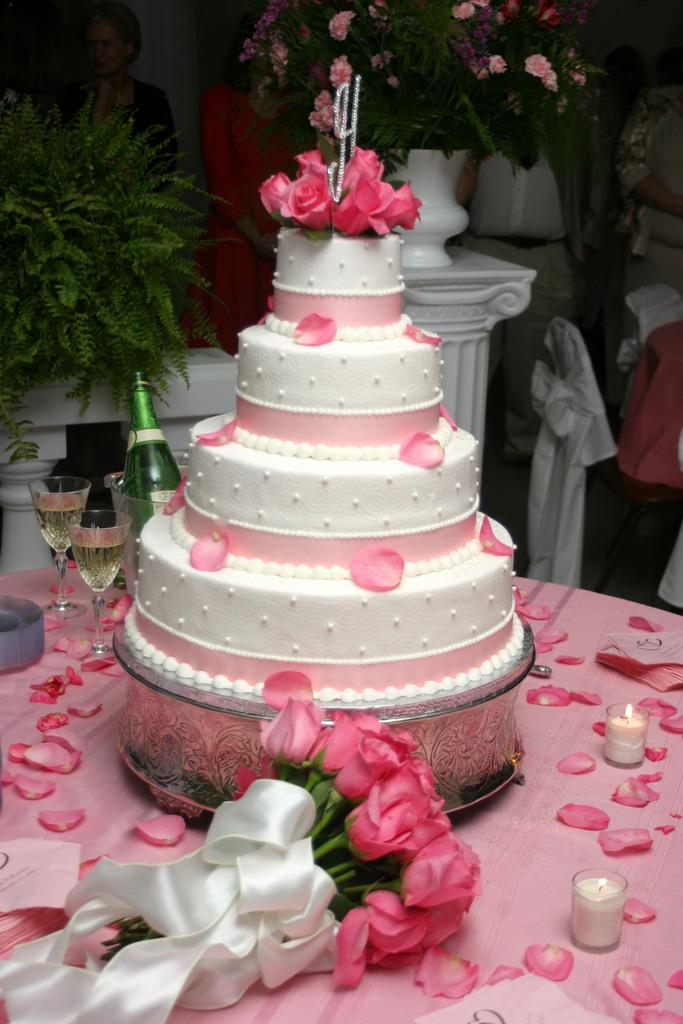What type of cake is shown in the image? There is a four-layer white and pink cake in the image. What decorations are on the cake? The cake has rose petals on it. What other floral elements can be seen in the image? There is a rose bouquet in the image, and flowers are visible at the back of the image. What beverages are present in the image? There are glasses of drink and a glass bottle in the image. What type of jail can be seen in the image? There is no jail present in the image; it features a cake, flowers, and beverages. How does the hydrant contribute to the decoration of the cake in the image? There is no hydrant present in the image; it is not related to the cake or its decoration. 